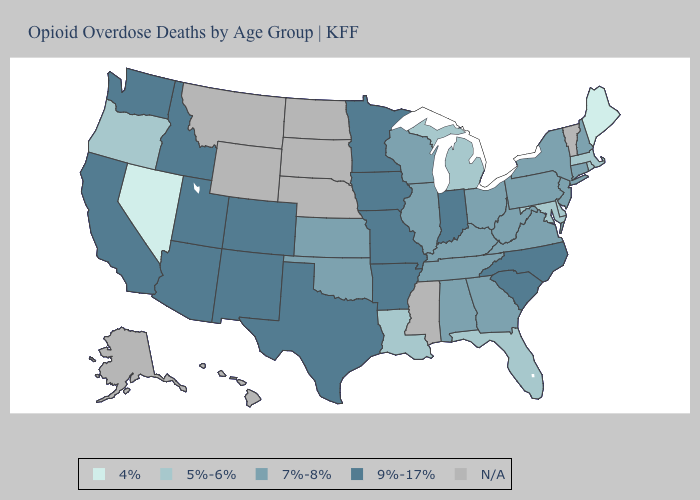Does Georgia have the lowest value in the South?
Short answer required. No. What is the value of Mississippi?
Answer briefly. N/A. Name the states that have a value in the range 7%-8%?
Quick response, please. Alabama, Connecticut, Georgia, Illinois, Kansas, Kentucky, New Hampshire, New Jersey, New York, Ohio, Oklahoma, Pennsylvania, Tennessee, Virginia, West Virginia, Wisconsin. What is the lowest value in the USA?
Quick response, please. 4%. Does Oregon have the highest value in the West?
Concise answer only. No. Among the states that border Colorado , which have the highest value?
Be succinct. Arizona, New Mexico, Utah. Does the map have missing data?
Be succinct. Yes. What is the value of Nebraska?
Short answer required. N/A. What is the highest value in the USA?
Keep it brief. 9%-17%. Is the legend a continuous bar?
Give a very brief answer. No. Does the first symbol in the legend represent the smallest category?
Write a very short answer. Yes. Name the states that have a value in the range 4%?
Give a very brief answer. Maine, Nevada. Does the map have missing data?
Answer briefly. Yes. Does the first symbol in the legend represent the smallest category?
Quick response, please. Yes. What is the value of Colorado?
Short answer required. 9%-17%. 